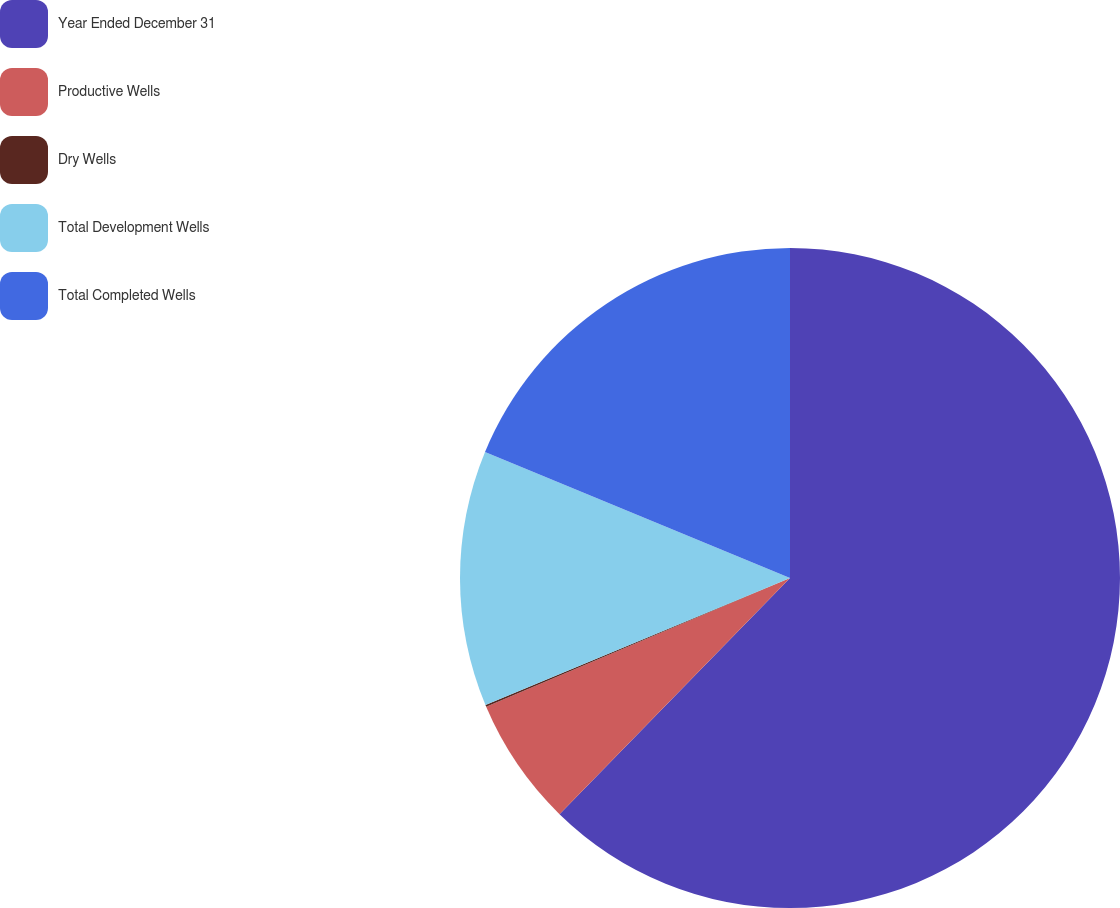Convert chart. <chart><loc_0><loc_0><loc_500><loc_500><pie_chart><fcel>Year Ended December 31<fcel>Productive Wells<fcel>Dry Wells<fcel>Total Development Wells<fcel>Total Completed Wells<nl><fcel>62.3%<fcel>6.31%<fcel>0.09%<fcel>12.53%<fcel>18.76%<nl></chart> 